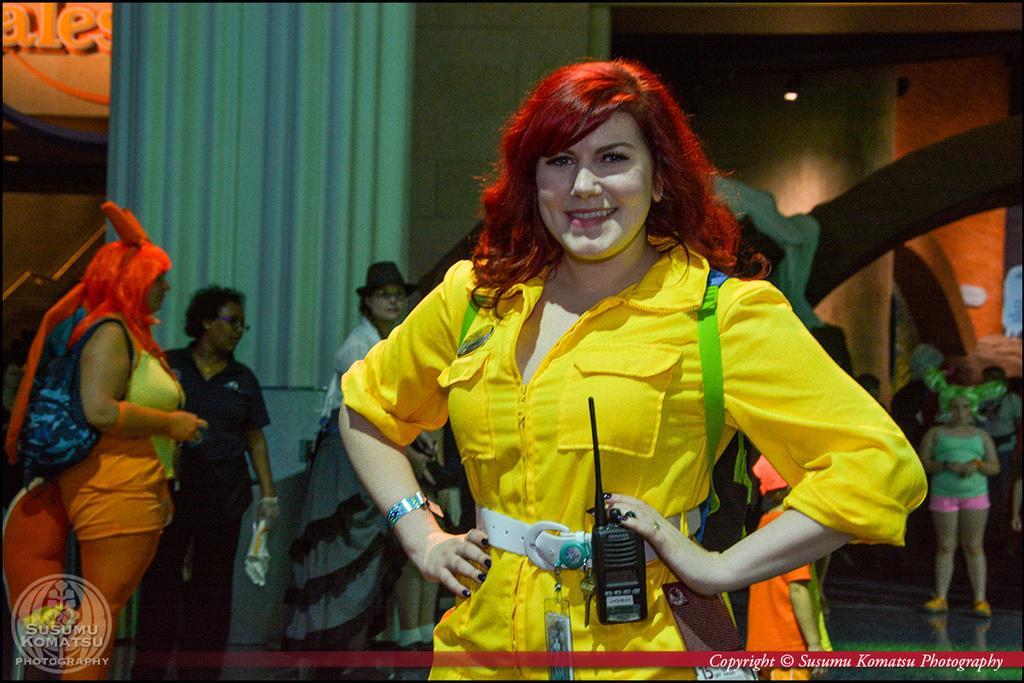Please provide a concise description of this image. The woman in front of the picture wearing yellow dress is standing and she is posing for the photo. She is smiling. Behind her, we see people standing. Behind them, we see a curtain in white and blue color. Beside that, we see a wall. This picture is clicked inside the room. On the left top, we see a board with some text written. 